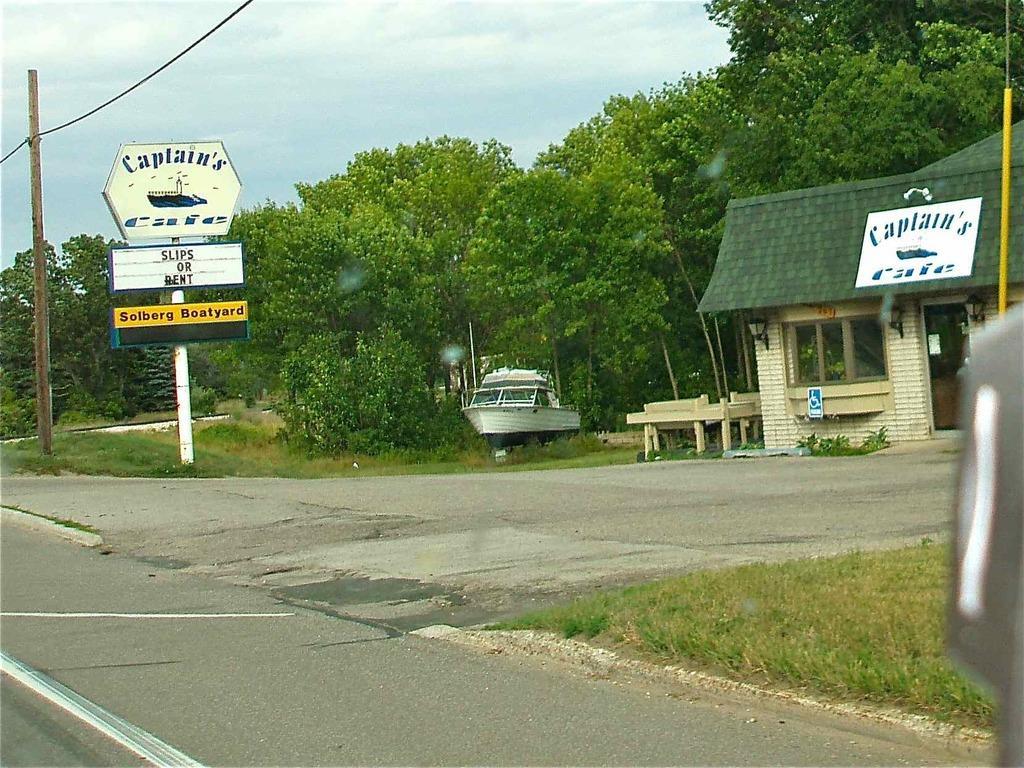How would you summarize this image in a sentence or two? In the image there is a road around the road there is grass, a pole and few boards with some names, a boat, trees and on the right side there is a house. 